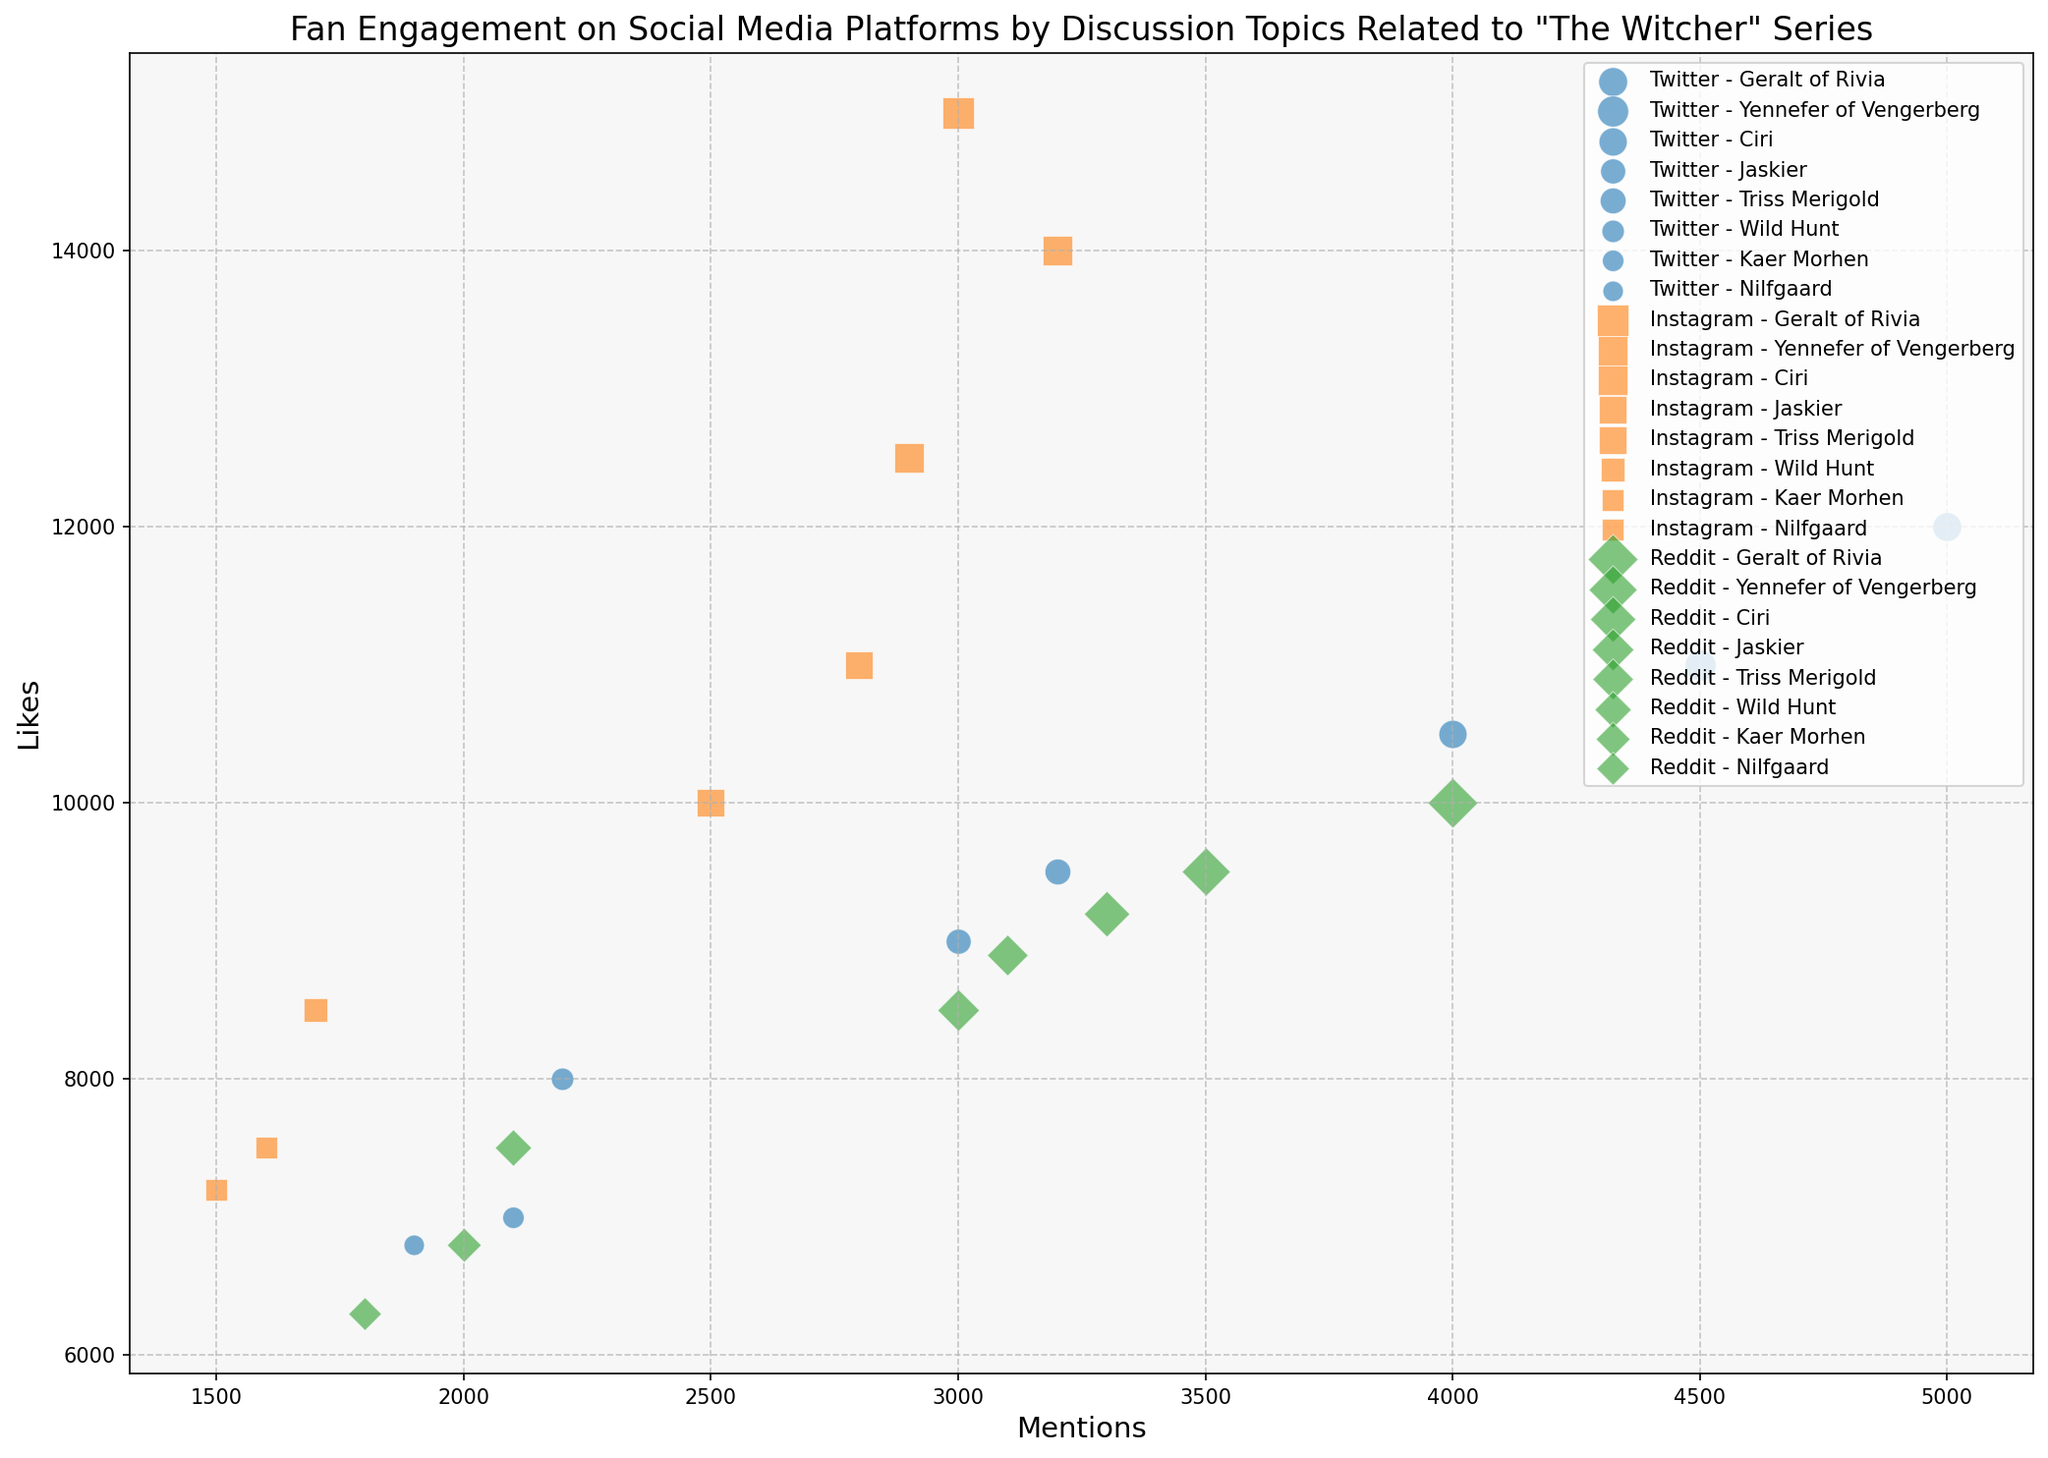Which topic has the most likes on Instagram? Looking at the bubbles for Instagram, the largest y-value (likes) represents "Geralt of Rivia" with 15,000 likes.
Answer: Geralt of Rivia Which platform has the highest number of mentions for the topic "Ciri"? By observing the bubbles for "Ciri" across platforms, Twitter has the highest x-value (mentions) with 4,000 mentions.
Answer: Twitter What is the total number of mentions for the topic "Jaskier" across all platforms? Summing the x-values (mentions) for "Jaskier" across Twitter, Instagram, and Reddit gives 3,000 + 2,500 + 3,000 = 8,500 mentions.
Answer: 8,500 For the topic "Wild Hunt", which platform has the smallest number of comments? Checking the bubble sizes for "Wild Hunt" across platforms, Instagram has the smallest size representing 1,300 comments.
Answer: Instagram Which platform has the most comments for the topic "Triss Merigold"? By comparing the bubble sizes (comments) for "Triss Merigold", Reddit has the largest size with 2,000 comments.
Answer: Reddit Compare the number of mentions between "Kaer Morhen" on Instagram and Reddit. Which is higher? Checking the x-values for "Kaer Morhen", Instagram has 1,600 mentions, whereas Reddit has 2,000 mentions; thus, Reddit is higher.
Answer: Reddit What is the average number of likes for "Yennefer of Vengerberg" on all platforms? Summing the likes (y-values) for "Yennefer of Vengerberg" gives 11,000 (Twitter) + 14,000 (Instagram) + 9,500 (Reddit) = 34,500, and the average is 34,500 / 3 = 11,500.
Answer: 11,500 Which topic has the lowest engagement in terms of likes on Reddit? Observing the lowest y-value (likes) for Reddit bubbles, "Nilfgaard" has the lowest with 6,300 likes.
Answer: Nilfgaard 